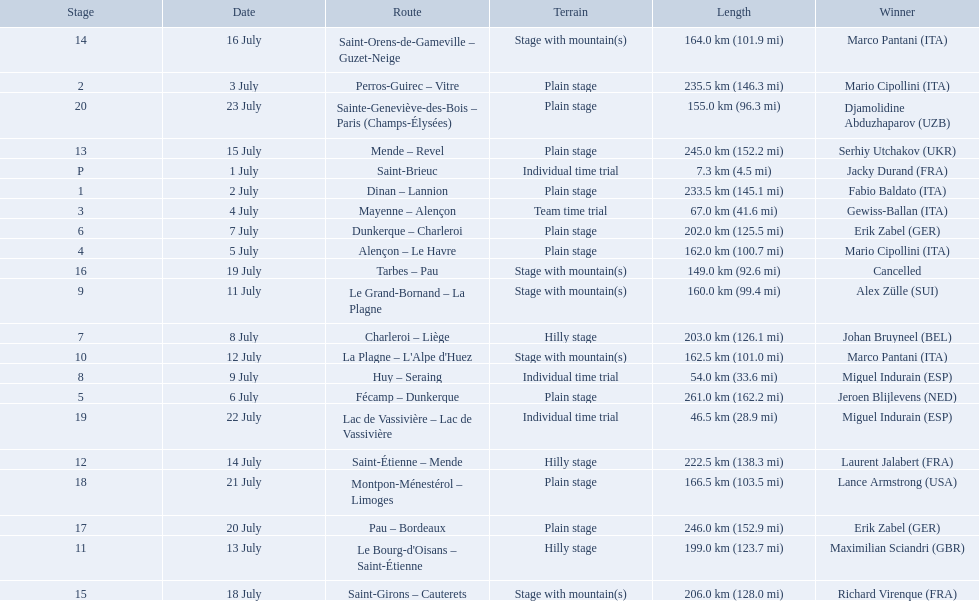What were the lengths of all the stages of the 1995 tour de france? 7.3 km (4.5 mi), 233.5 km (145.1 mi), 235.5 km (146.3 mi), 67.0 km (41.6 mi), 162.0 km (100.7 mi), 261.0 km (162.2 mi), 202.0 km (125.5 mi), 203.0 km (126.1 mi), 54.0 km (33.6 mi), 160.0 km (99.4 mi), 162.5 km (101.0 mi), 199.0 km (123.7 mi), 222.5 km (138.3 mi), 245.0 km (152.2 mi), 164.0 km (101.9 mi), 206.0 km (128.0 mi), 149.0 km (92.6 mi), 246.0 km (152.9 mi), 166.5 km (103.5 mi), 46.5 km (28.9 mi), 155.0 km (96.3 mi). Of those, which one occurred on july 8th? 203.0 km (126.1 mi). 